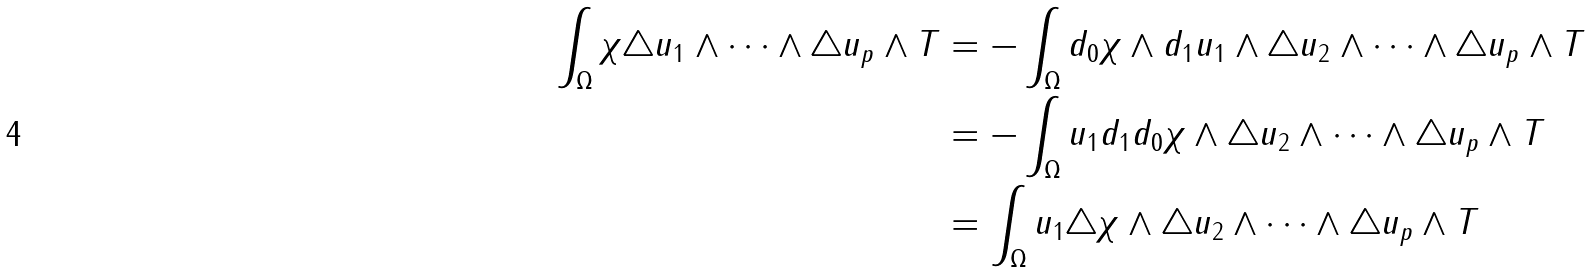<formula> <loc_0><loc_0><loc_500><loc_500>\int _ { \Omega } \chi \triangle u _ { 1 } \wedge \dots \wedge \triangle u _ { p } \wedge T & = - \int _ { \Omega } d _ { 0 } \chi \wedge d _ { 1 } u _ { 1 } \wedge \triangle u _ { 2 } \wedge \dots \wedge \triangle u _ { p } \wedge T \\ & = - \int _ { \Omega } u _ { 1 } d _ { 1 } d _ { 0 } \chi \wedge \triangle u _ { 2 } \wedge \dots \wedge \triangle u _ { p } \wedge T \\ & = \int _ { \Omega } u _ { 1 } \triangle \chi \wedge \triangle u _ { 2 } \wedge \dots \wedge \triangle u _ { p } \wedge T</formula> 